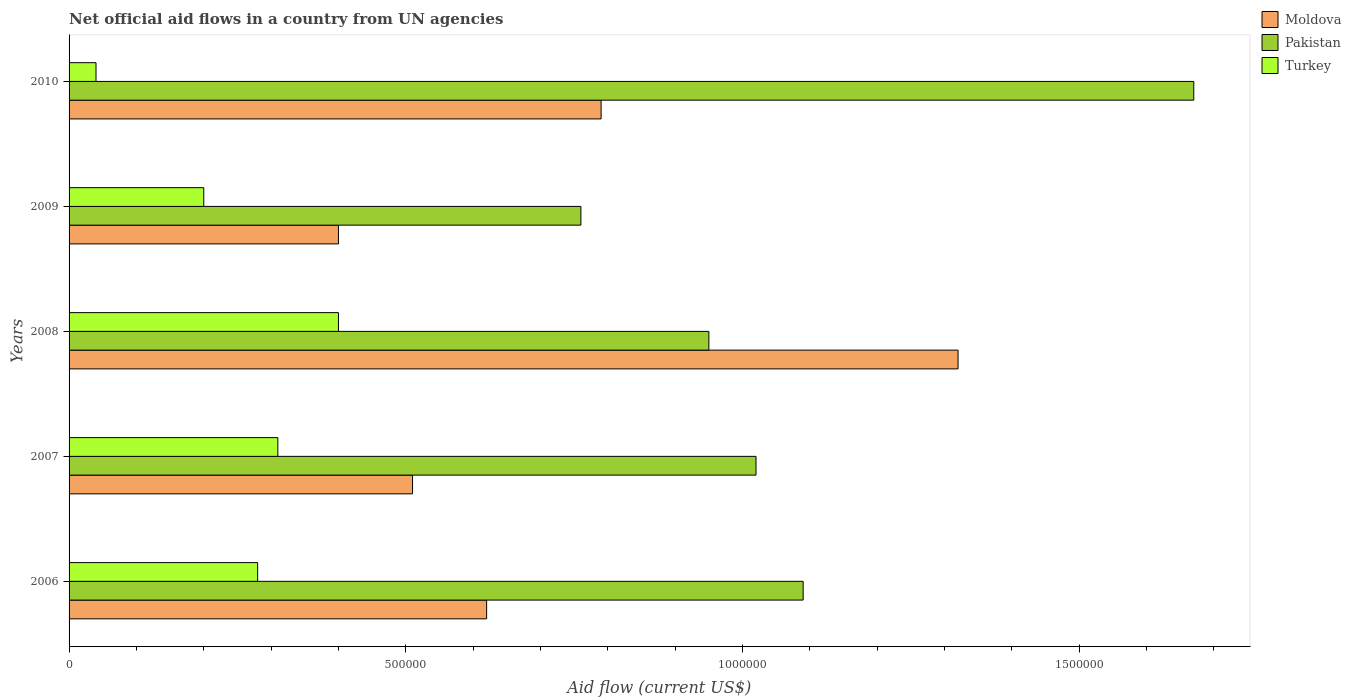How many different coloured bars are there?
Your answer should be compact. 3. How many groups of bars are there?
Give a very brief answer. 5. Are the number of bars per tick equal to the number of legend labels?
Keep it short and to the point. Yes. How many bars are there on the 2nd tick from the top?
Offer a terse response. 3. How many bars are there on the 5th tick from the bottom?
Your answer should be compact. 3. What is the label of the 1st group of bars from the top?
Your response must be concise. 2010. In how many cases, is the number of bars for a given year not equal to the number of legend labels?
Your response must be concise. 0. What is the net official aid flow in Moldova in 2010?
Ensure brevity in your answer.  7.90e+05. Across all years, what is the minimum net official aid flow in Moldova?
Provide a short and direct response. 4.00e+05. What is the total net official aid flow in Pakistan in the graph?
Ensure brevity in your answer.  5.49e+06. What is the difference between the net official aid flow in Moldova in 2007 and that in 2010?
Give a very brief answer. -2.80e+05. What is the difference between the net official aid flow in Moldova in 2009 and the net official aid flow in Pakistan in 2007?
Provide a succinct answer. -6.20e+05. What is the average net official aid flow in Moldova per year?
Ensure brevity in your answer.  7.28e+05. In the year 2006, what is the difference between the net official aid flow in Pakistan and net official aid flow in Turkey?
Ensure brevity in your answer.  8.10e+05. In how many years, is the net official aid flow in Turkey greater than 1200000 US$?
Provide a succinct answer. 0. What is the difference between the highest and the second highest net official aid flow in Moldova?
Keep it short and to the point. 5.30e+05. In how many years, is the net official aid flow in Turkey greater than the average net official aid flow in Turkey taken over all years?
Your answer should be very brief. 3. Is the sum of the net official aid flow in Moldova in 2008 and 2009 greater than the maximum net official aid flow in Pakistan across all years?
Ensure brevity in your answer.  Yes. What does the 3rd bar from the top in 2010 represents?
Provide a short and direct response. Moldova. What does the 1st bar from the bottom in 2010 represents?
Keep it short and to the point. Moldova. Is it the case that in every year, the sum of the net official aid flow in Moldova and net official aid flow in Pakistan is greater than the net official aid flow in Turkey?
Your answer should be very brief. Yes. Are all the bars in the graph horizontal?
Your response must be concise. Yes. What is the difference between two consecutive major ticks on the X-axis?
Your answer should be very brief. 5.00e+05. Are the values on the major ticks of X-axis written in scientific E-notation?
Make the answer very short. No. Where does the legend appear in the graph?
Provide a succinct answer. Top right. How many legend labels are there?
Your answer should be compact. 3. How are the legend labels stacked?
Provide a short and direct response. Vertical. What is the title of the graph?
Make the answer very short. Net official aid flows in a country from UN agencies. Does "Chile" appear as one of the legend labels in the graph?
Your response must be concise. No. What is the label or title of the X-axis?
Ensure brevity in your answer.  Aid flow (current US$). What is the Aid flow (current US$) of Moldova in 2006?
Your answer should be very brief. 6.20e+05. What is the Aid flow (current US$) of Pakistan in 2006?
Provide a short and direct response. 1.09e+06. What is the Aid flow (current US$) of Turkey in 2006?
Your response must be concise. 2.80e+05. What is the Aid flow (current US$) in Moldova in 2007?
Your answer should be very brief. 5.10e+05. What is the Aid flow (current US$) of Pakistan in 2007?
Your answer should be very brief. 1.02e+06. What is the Aid flow (current US$) in Moldova in 2008?
Provide a succinct answer. 1.32e+06. What is the Aid flow (current US$) of Pakistan in 2008?
Your response must be concise. 9.50e+05. What is the Aid flow (current US$) of Pakistan in 2009?
Offer a very short reply. 7.60e+05. What is the Aid flow (current US$) in Moldova in 2010?
Ensure brevity in your answer.  7.90e+05. What is the Aid flow (current US$) of Pakistan in 2010?
Your answer should be compact. 1.67e+06. What is the Aid flow (current US$) of Turkey in 2010?
Your answer should be compact. 4.00e+04. Across all years, what is the maximum Aid flow (current US$) of Moldova?
Keep it short and to the point. 1.32e+06. Across all years, what is the maximum Aid flow (current US$) in Pakistan?
Your answer should be very brief. 1.67e+06. Across all years, what is the minimum Aid flow (current US$) in Pakistan?
Provide a short and direct response. 7.60e+05. What is the total Aid flow (current US$) of Moldova in the graph?
Provide a succinct answer. 3.64e+06. What is the total Aid flow (current US$) of Pakistan in the graph?
Your answer should be compact. 5.49e+06. What is the total Aid flow (current US$) in Turkey in the graph?
Offer a very short reply. 1.23e+06. What is the difference between the Aid flow (current US$) of Pakistan in 2006 and that in 2007?
Ensure brevity in your answer.  7.00e+04. What is the difference between the Aid flow (current US$) in Moldova in 2006 and that in 2008?
Ensure brevity in your answer.  -7.00e+05. What is the difference between the Aid flow (current US$) in Moldova in 2006 and that in 2009?
Provide a succinct answer. 2.20e+05. What is the difference between the Aid flow (current US$) of Pakistan in 2006 and that in 2009?
Your answer should be compact. 3.30e+05. What is the difference between the Aid flow (current US$) of Moldova in 2006 and that in 2010?
Make the answer very short. -1.70e+05. What is the difference between the Aid flow (current US$) of Pakistan in 2006 and that in 2010?
Give a very brief answer. -5.80e+05. What is the difference between the Aid flow (current US$) in Moldova in 2007 and that in 2008?
Provide a short and direct response. -8.10e+05. What is the difference between the Aid flow (current US$) of Moldova in 2007 and that in 2009?
Offer a very short reply. 1.10e+05. What is the difference between the Aid flow (current US$) in Moldova in 2007 and that in 2010?
Your response must be concise. -2.80e+05. What is the difference between the Aid flow (current US$) in Pakistan in 2007 and that in 2010?
Provide a succinct answer. -6.50e+05. What is the difference between the Aid flow (current US$) in Moldova in 2008 and that in 2009?
Give a very brief answer. 9.20e+05. What is the difference between the Aid flow (current US$) of Pakistan in 2008 and that in 2009?
Your answer should be compact. 1.90e+05. What is the difference between the Aid flow (current US$) in Moldova in 2008 and that in 2010?
Ensure brevity in your answer.  5.30e+05. What is the difference between the Aid flow (current US$) in Pakistan in 2008 and that in 2010?
Give a very brief answer. -7.20e+05. What is the difference between the Aid flow (current US$) of Moldova in 2009 and that in 2010?
Your answer should be very brief. -3.90e+05. What is the difference between the Aid flow (current US$) in Pakistan in 2009 and that in 2010?
Offer a terse response. -9.10e+05. What is the difference between the Aid flow (current US$) in Turkey in 2009 and that in 2010?
Keep it short and to the point. 1.60e+05. What is the difference between the Aid flow (current US$) of Moldova in 2006 and the Aid flow (current US$) of Pakistan in 2007?
Make the answer very short. -4.00e+05. What is the difference between the Aid flow (current US$) in Pakistan in 2006 and the Aid flow (current US$) in Turkey in 2007?
Keep it short and to the point. 7.80e+05. What is the difference between the Aid flow (current US$) of Moldova in 2006 and the Aid flow (current US$) of Pakistan in 2008?
Provide a short and direct response. -3.30e+05. What is the difference between the Aid flow (current US$) in Pakistan in 2006 and the Aid flow (current US$) in Turkey in 2008?
Make the answer very short. 6.90e+05. What is the difference between the Aid flow (current US$) of Moldova in 2006 and the Aid flow (current US$) of Turkey in 2009?
Your answer should be compact. 4.20e+05. What is the difference between the Aid flow (current US$) in Pakistan in 2006 and the Aid flow (current US$) in Turkey in 2009?
Offer a very short reply. 8.90e+05. What is the difference between the Aid flow (current US$) in Moldova in 2006 and the Aid flow (current US$) in Pakistan in 2010?
Keep it short and to the point. -1.05e+06. What is the difference between the Aid flow (current US$) of Moldova in 2006 and the Aid flow (current US$) of Turkey in 2010?
Your answer should be very brief. 5.80e+05. What is the difference between the Aid flow (current US$) in Pakistan in 2006 and the Aid flow (current US$) in Turkey in 2010?
Your answer should be compact. 1.05e+06. What is the difference between the Aid flow (current US$) in Moldova in 2007 and the Aid flow (current US$) in Pakistan in 2008?
Your answer should be very brief. -4.40e+05. What is the difference between the Aid flow (current US$) of Pakistan in 2007 and the Aid flow (current US$) of Turkey in 2008?
Offer a terse response. 6.20e+05. What is the difference between the Aid flow (current US$) in Moldova in 2007 and the Aid flow (current US$) in Pakistan in 2009?
Your answer should be compact. -2.50e+05. What is the difference between the Aid flow (current US$) of Pakistan in 2007 and the Aid flow (current US$) of Turkey in 2009?
Your response must be concise. 8.20e+05. What is the difference between the Aid flow (current US$) in Moldova in 2007 and the Aid flow (current US$) in Pakistan in 2010?
Offer a terse response. -1.16e+06. What is the difference between the Aid flow (current US$) in Moldova in 2007 and the Aid flow (current US$) in Turkey in 2010?
Make the answer very short. 4.70e+05. What is the difference between the Aid flow (current US$) of Pakistan in 2007 and the Aid flow (current US$) of Turkey in 2010?
Keep it short and to the point. 9.80e+05. What is the difference between the Aid flow (current US$) in Moldova in 2008 and the Aid flow (current US$) in Pakistan in 2009?
Offer a very short reply. 5.60e+05. What is the difference between the Aid flow (current US$) in Moldova in 2008 and the Aid flow (current US$) in Turkey in 2009?
Give a very brief answer. 1.12e+06. What is the difference between the Aid flow (current US$) in Pakistan in 2008 and the Aid flow (current US$) in Turkey in 2009?
Ensure brevity in your answer.  7.50e+05. What is the difference between the Aid flow (current US$) in Moldova in 2008 and the Aid flow (current US$) in Pakistan in 2010?
Give a very brief answer. -3.50e+05. What is the difference between the Aid flow (current US$) of Moldova in 2008 and the Aid flow (current US$) of Turkey in 2010?
Give a very brief answer. 1.28e+06. What is the difference between the Aid flow (current US$) of Pakistan in 2008 and the Aid flow (current US$) of Turkey in 2010?
Offer a very short reply. 9.10e+05. What is the difference between the Aid flow (current US$) of Moldova in 2009 and the Aid flow (current US$) of Pakistan in 2010?
Your response must be concise. -1.27e+06. What is the difference between the Aid flow (current US$) in Moldova in 2009 and the Aid flow (current US$) in Turkey in 2010?
Make the answer very short. 3.60e+05. What is the difference between the Aid flow (current US$) of Pakistan in 2009 and the Aid flow (current US$) of Turkey in 2010?
Your response must be concise. 7.20e+05. What is the average Aid flow (current US$) in Moldova per year?
Provide a short and direct response. 7.28e+05. What is the average Aid flow (current US$) in Pakistan per year?
Keep it short and to the point. 1.10e+06. What is the average Aid flow (current US$) of Turkey per year?
Your answer should be compact. 2.46e+05. In the year 2006, what is the difference between the Aid flow (current US$) in Moldova and Aid flow (current US$) in Pakistan?
Your answer should be very brief. -4.70e+05. In the year 2006, what is the difference between the Aid flow (current US$) of Pakistan and Aid flow (current US$) of Turkey?
Offer a terse response. 8.10e+05. In the year 2007, what is the difference between the Aid flow (current US$) in Moldova and Aid flow (current US$) in Pakistan?
Offer a terse response. -5.10e+05. In the year 2007, what is the difference between the Aid flow (current US$) of Moldova and Aid flow (current US$) of Turkey?
Your response must be concise. 2.00e+05. In the year 2007, what is the difference between the Aid flow (current US$) in Pakistan and Aid flow (current US$) in Turkey?
Offer a terse response. 7.10e+05. In the year 2008, what is the difference between the Aid flow (current US$) in Moldova and Aid flow (current US$) in Pakistan?
Keep it short and to the point. 3.70e+05. In the year 2008, what is the difference between the Aid flow (current US$) in Moldova and Aid flow (current US$) in Turkey?
Your response must be concise. 9.20e+05. In the year 2008, what is the difference between the Aid flow (current US$) in Pakistan and Aid flow (current US$) in Turkey?
Ensure brevity in your answer.  5.50e+05. In the year 2009, what is the difference between the Aid flow (current US$) in Moldova and Aid flow (current US$) in Pakistan?
Make the answer very short. -3.60e+05. In the year 2009, what is the difference between the Aid flow (current US$) of Pakistan and Aid flow (current US$) of Turkey?
Keep it short and to the point. 5.60e+05. In the year 2010, what is the difference between the Aid flow (current US$) of Moldova and Aid flow (current US$) of Pakistan?
Offer a very short reply. -8.80e+05. In the year 2010, what is the difference between the Aid flow (current US$) of Moldova and Aid flow (current US$) of Turkey?
Provide a short and direct response. 7.50e+05. In the year 2010, what is the difference between the Aid flow (current US$) of Pakistan and Aid flow (current US$) of Turkey?
Your response must be concise. 1.63e+06. What is the ratio of the Aid flow (current US$) in Moldova in 2006 to that in 2007?
Offer a very short reply. 1.22. What is the ratio of the Aid flow (current US$) of Pakistan in 2006 to that in 2007?
Make the answer very short. 1.07. What is the ratio of the Aid flow (current US$) of Turkey in 2006 to that in 2007?
Provide a short and direct response. 0.9. What is the ratio of the Aid flow (current US$) in Moldova in 2006 to that in 2008?
Offer a terse response. 0.47. What is the ratio of the Aid flow (current US$) in Pakistan in 2006 to that in 2008?
Give a very brief answer. 1.15. What is the ratio of the Aid flow (current US$) in Turkey in 2006 to that in 2008?
Your answer should be compact. 0.7. What is the ratio of the Aid flow (current US$) in Moldova in 2006 to that in 2009?
Your answer should be compact. 1.55. What is the ratio of the Aid flow (current US$) in Pakistan in 2006 to that in 2009?
Provide a short and direct response. 1.43. What is the ratio of the Aid flow (current US$) in Moldova in 2006 to that in 2010?
Make the answer very short. 0.78. What is the ratio of the Aid flow (current US$) of Pakistan in 2006 to that in 2010?
Your answer should be compact. 0.65. What is the ratio of the Aid flow (current US$) in Moldova in 2007 to that in 2008?
Give a very brief answer. 0.39. What is the ratio of the Aid flow (current US$) of Pakistan in 2007 to that in 2008?
Give a very brief answer. 1.07. What is the ratio of the Aid flow (current US$) in Turkey in 2007 to that in 2008?
Offer a terse response. 0.78. What is the ratio of the Aid flow (current US$) in Moldova in 2007 to that in 2009?
Provide a succinct answer. 1.27. What is the ratio of the Aid flow (current US$) in Pakistan in 2007 to that in 2009?
Your answer should be compact. 1.34. What is the ratio of the Aid flow (current US$) in Turkey in 2007 to that in 2009?
Make the answer very short. 1.55. What is the ratio of the Aid flow (current US$) of Moldova in 2007 to that in 2010?
Keep it short and to the point. 0.65. What is the ratio of the Aid flow (current US$) of Pakistan in 2007 to that in 2010?
Your response must be concise. 0.61. What is the ratio of the Aid flow (current US$) of Turkey in 2007 to that in 2010?
Your response must be concise. 7.75. What is the ratio of the Aid flow (current US$) of Moldova in 2008 to that in 2009?
Provide a succinct answer. 3.3. What is the ratio of the Aid flow (current US$) in Turkey in 2008 to that in 2009?
Provide a succinct answer. 2. What is the ratio of the Aid flow (current US$) of Moldova in 2008 to that in 2010?
Keep it short and to the point. 1.67. What is the ratio of the Aid flow (current US$) in Pakistan in 2008 to that in 2010?
Provide a succinct answer. 0.57. What is the ratio of the Aid flow (current US$) in Turkey in 2008 to that in 2010?
Ensure brevity in your answer.  10. What is the ratio of the Aid flow (current US$) in Moldova in 2009 to that in 2010?
Give a very brief answer. 0.51. What is the ratio of the Aid flow (current US$) in Pakistan in 2009 to that in 2010?
Provide a short and direct response. 0.46. What is the difference between the highest and the second highest Aid flow (current US$) of Moldova?
Make the answer very short. 5.30e+05. What is the difference between the highest and the second highest Aid flow (current US$) of Pakistan?
Offer a terse response. 5.80e+05. What is the difference between the highest and the second highest Aid flow (current US$) in Turkey?
Ensure brevity in your answer.  9.00e+04. What is the difference between the highest and the lowest Aid flow (current US$) of Moldova?
Your response must be concise. 9.20e+05. What is the difference between the highest and the lowest Aid flow (current US$) in Pakistan?
Provide a succinct answer. 9.10e+05. What is the difference between the highest and the lowest Aid flow (current US$) in Turkey?
Provide a succinct answer. 3.60e+05. 